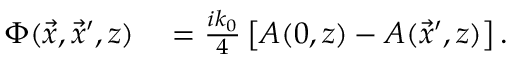<formula> <loc_0><loc_0><loc_500><loc_500>\begin{array} { r l } { \Phi ( \vec { x } , \vec { x } ^ { \prime } , z ) } & = \frac { i k _ { 0 } } { 4 } \left [ A ( 0 , z ) - A ( \vec { x } ^ { \prime } , z ) \right ] . } \end{array}</formula> 